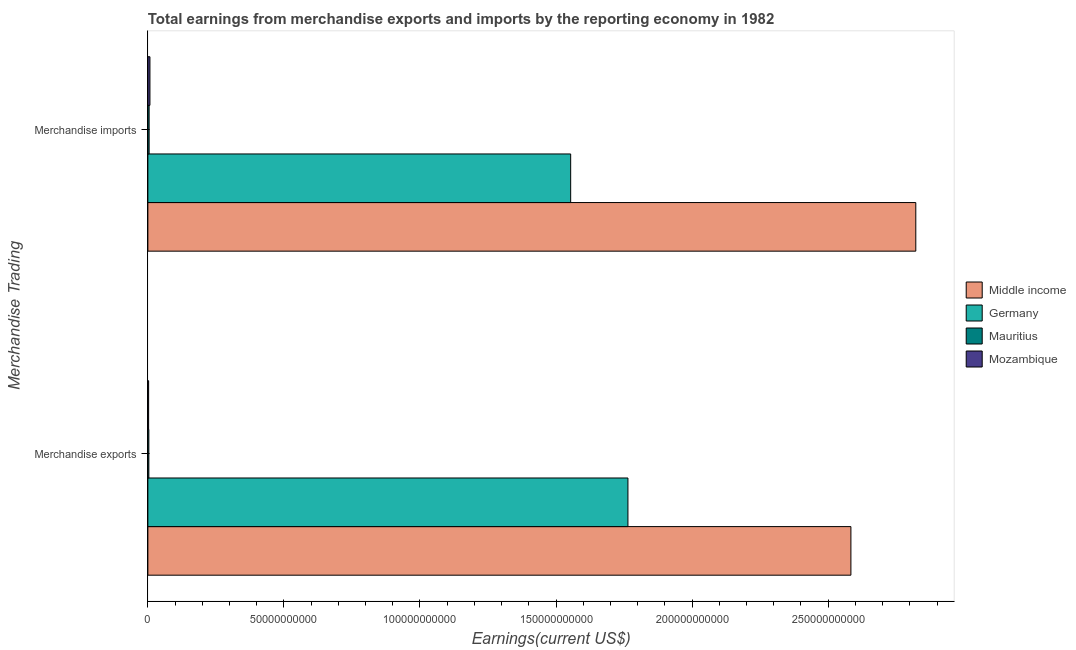Are the number of bars per tick equal to the number of legend labels?
Make the answer very short. Yes. What is the earnings from merchandise imports in Mozambique?
Provide a succinct answer. 7.59e+08. Across all countries, what is the maximum earnings from merchandise imports?
Your answer should be very brief. 2.82e+11. Across all countries, what is the minimum earnings from merchandise exports?
Provide a short and direct response. 2.78e+08. In which country was the earnings from merchandise exports minimum?
Provide a short and direct response. Mozambique. What is the total earnings from merchandise imports in the graph?
Make the answer very short. 4.39e+11. What is the difference between the earnings from merchandise exports in Germany and that in Middle income?
Ensure brevity in your answer.  -8.19e+1. What is the difference between the earnings from merchandise exports in Mozambique and the earnings from merchandise imports in Middle income?
Offer a terse response. -2.82e+11. What is the average earnings from merchandise exports per country?
Make the answer very short. 1.09e+11. What is the difference between the earnings from merchandise imports and earnings from merchandise exports in Middle income?
Make the answer very short. 2.38e+1. What is the ratio of the earnings from merchandise imports in Middle income to that in Mauritius?
Ensure brevity in your answer.  609.69. Is the earnings from merchandise imports in Mozambique less than that in Middle income?
Ensure brevity in your answer.  Yes. What does the 2nd bar from the top in Merchandise exports represents?
Provide a short and direct response. Mauritius. How many bars are there?
Your answer should be compact. 8. How many countries are there in the graph?
Offer a terse response. 4. Where does the legend appear in the graph?
Ensure brevity in your answer.  Center right. How many legend labels are there?
Your answer should be very brief. 4. How are the legend labels stacked?
Provide a short and direct response. Vertical. What is the title of the graph?
Keep it short and to the point. Total earnings from merchandise exports and imports by the reporting economy in 1982. Does "Cayman Islands" appear as one of the legend labels in the graph?
Your answer should be compact. No. What is the label or title of the X-axis?
Offer a terse response. Earnings(current US$). What is the label or title of the Y-axis?
Provide a succinct answer. Merchandise Trading. What is the Earnings(current US$) in Middle income in Merchandise exports?
Provide a succinct answer. 2.58e+11. What is the Earnings(current US$) in Germany in Merchandise exports?
Provide a succinct answer. 1.76e+11. What is the Earnings(current US$) of Mauritius in Merchandise exports?
Offer a terse response. 3.59e+08. What is the Earnings(current US$) of Mozambique in Merchandise exports?
Your answer should be very brief. 2.78e+08. What is the Earnings(current US$) in Middle income in Merchandise imports?
Keep it short and to the point. 2.82e+11. What is the Earnings(current US$) of Germany in Merchandise imports?
Your answer should be very brief. 1.55e+11. What is the Earnings(current US$) in Mauritius in Merchandise imports?
Make the answer very short. 4.63e+08. What is the Earnings(current US$) of Mozambique in Merchandise imports?
Ensure brevity in your answer.  7.59e+08. Across all Merchandise Trading, what is the maximum Earnings(current US$) of Middle income?
Provide a short and direct response. 2.82e+11. Across all Merchandise Trading, what is the maximum Earnings(current US$) in Germany?
Your answer should be compact. 1.76e+11. Across all Merchandise Trading, what is the maximum Earnings(current US$) in Mauritius?
Ensure brevity in your answer.  4.63e+08. Across all Merchandise Trading, what is the maximum Earnings(current US$) in Mozambique?
Give a very brief answer. 7.59e+08. Across all Merchandise Trading, what is the minimum Earnings(current US$) of Middle income?
Your response must be concise. 2.58e+11. Across all Merchandise Trading, what is the minimum Earnings(current US$) of Germany?
Your answer should be compact. 1.55e+11. Across all Merchandise Trading, what is the minimum Earnings(current US$) of Mauritius?
Ensure brevity in your answer.  3.59e+08. Across all Merchandise Trading, what is the minimum Earnings(current US$) in Mozambique?
Your answer should be compact. 2.78e+08. What is the total Earnings(current US$) in Middle income in the graph?
Keep it short and to the point. 5.41e+11. What is the total Earnings(current US$) in Germany in the graph?
Provide a succinct answer. 3.32e+11. What is the total Earnings(current US$) in Mauritius in the graph?
Make the answer very short. 8.22e+08. What is the total Earnings(current US$) of Mozambique in the graph?
Provide a short and direct response. 1.04e+09. What is the difference between the Earnings(current US$) of Middle income in Merchandise exports and that in Merchandise imports?
Make the answer very short. -2.38e+1. What is the difference between the Earnings(current US$) of Germany in Merchandise exports and that in Merchandise imports?
Your answer should be very brief. 2.10e+1. What is the difference between the Earnings(current US$) of Mauritius in Merchandise exports and that in Merchandise imports?
Ensure brevity in your answer.  -1.04e+08. What is the difference between the Earnings(current US$) of Mozambique in Merchandise exports and that in Merchandise imports?
Your answer should be compact. -4.82e+08. What is the difference between the Earnings(current US$) in Middle income in Merchandise exports and the Earnings(current US$) in Germany in Merchandise imports?
Give a very brief answer. 1.03e+11. What is the difference between the Earnings(current US$) in Middle income in Merchandise exports and the Earnings(current US$) in Mauritius in Merchandise imports?
Provide a short and direct response. 2.58e+11. What is the difference between the Earnings(current US$) of Middle income in Merchandise exports and the Earnings(current US$) of Mozambique in Merchandise imports?
Provide a short and direct response. 2.58e+11. What is the difference between the Earnings(current US$) of Germany in Merchandise exports and the Earnings(current US$) of Mauritius in Merchandise imports?
Give a very brief answer. 1.76e+11. What is the difference between the Earnings(current US$) of Germany in Merchandise exports and the Earnings(current US$) of Mozambique in Merchandise imports?
Make the answer very short. 1.76e+11. What is the difference between the Earnings(current US$) in Mauritius in Merchandise exports and the Earnings(current US$) in Mozambique in Merchandise imports?
Keep it short and to the point. -4.01e+08. What is the average Earnings(current US$) of Middle income per Merchandise Trading?
Keep it short and to the point. 2.70e+11. What is the average Earnings(current US$) of Germany per Merchandise Trading?
Provide a succinct answer. 1.66e+11. What is the average Earnings(current US$) of Mauritius per Merchandise Trading?
Offer a terse response. 4.11e+08. What is the average Earnings(current US$) in Mozambique per Merchandise Trading?
Your response must be concise. 5.19e+08. What is the difference between the Earnings(current US$) of Middle income and Earnings(current US$) of Germany in Merchandise exports?
Keep it short and to the point. 8.19e+1. What is the difference between the Earnings(current US$) in Middle income and Earnings(current US$) in Mauritius in Merchandise exports?
Offer a very short reply. 2.58e+11. What is the difference between the Earnings(current US$) of Middle income and Earnings(current US$) of Mozambique in Merchandise exports?
Give a very brief answer. 2.58e+11. What is the difference between the Earnings(current US$) of Germany and Earnings(current US$) of Mauritius in Merchandise exports?
Offer a terse response. 1.76e+11. What is the difference between the Earnings(current US$) in Germany and Earnings(current US$) in Mozambique in Merchandise exports?
Offer a very short reply. 1.76e+11. What is the difference between the Earnings(current US$) of Mauritius and Earnings(current US$) of Mozambique in Merchandise exports?
Provide a short and direct response. 8.09e+07. What is the difference between the Earnings(current US$) of Middle income and Earnings(current US$) of Germany in Merchandise imports?
Your response must be concise. 1.27e+11. What is the difference between the Earnings(current US$) of Middle income and Earnings(current US$) of Mauritius in Merchandise imports?
Your response must be concise. 2.82e+11. What is the difference between the Earnings(current US$) in Middle income and Earnings(current US$) in Mozambique in Merchandise imports?
Provide a short and direct response. 2.81e+11. What is the difference between the Earnings(current US$) of Germany and Earnings(current US$) of Mauritius in Merchandise imports?
Offer a terse response. 1.55e+11. What is the difference between the Earnings(current US$) of Germany and Earnings(current US$) of Mozambique in Merchandise imports?
Your response must be concise. 1.55e+11. What is the difference between the Earnings(current US$) of Mauritius and Earnings(current US$) of Mozambique in Merchandise imports?
Give a very brief answer. -2.97e+08. What is the ratio of the Earnings(current US$) of Middle income in Merchandise exports to that in Merchandise imports?
Offer a terse response. 0.92. What is the ratio of the Earnings(current US$) of Germany in Merchandise exports to that in Merchandise imports?
Your answer should be very brief. 1.14. What is the ratio of the Earnings(current US$) of Mauritius in Merchandise exports to that in Merchandise imports?
Provide a short and direct response. 0.77. What is the ratio of the Earnings(current US$) of Mozambique in Merchandise exports to that in Merchandise imports?
Give a very brief answer. 0.37. What is the difference between the highest and the second highest Earnings(current US$) of Middle income?
Ensure brevity in your answer.  2.38e+1. What is the difference between the highest and the second highest Earnings(current US$) in Germany?
Your answer should be compact. 2.10e+1. What is the difference between the highest and the second highest Earnings(current US$) of Mauritius?
Keep it short and to the point. 1.04e+08. What is the difference between the highest and the second highest Earnings(current US$) in Mozambique?
Your answer should be compact. 4.82e+08. What is the difference between the highest and the lowest Earnings(current US$) in Middle income?
Your answer should be compact. 2.38e+1. What is the difference between the highest and the lowest Earnings(current US$) in Germany?
Give a very brief answer. 2.10e+1. What is the difference between the highest and the lowest Earnings(current US$) of Mauritius?
Your response must be concise. 1.04e+08. What is the difference between the highest and the lowest Earnings(current US$) of Mozambique?
Your answer should be very brief. 4.82e+08. 